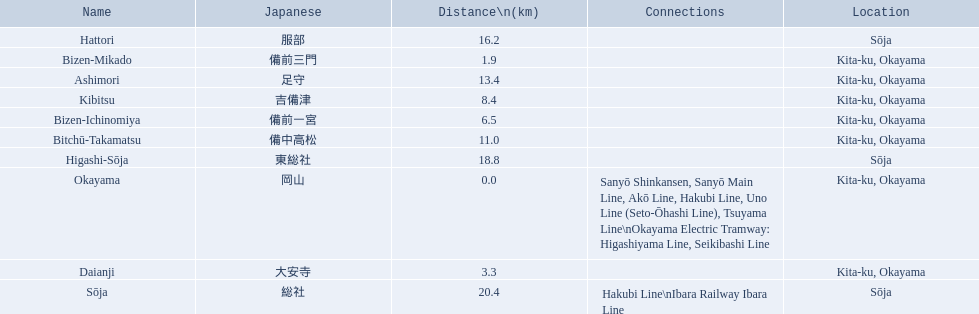What are all of the train names? Okayama, Bizen-Mikado, Daianji, Bizen-Ichinomiya, Kibitsu, Bitchū-Takamatsu, Ashimori, Hattori, Higashi-Sōja, Sōja. What is the distance for each? 0.0, 1.9, 3.3, 6.5, 8.4, 11.0, 13.4, 16.2, 18.8, 20.4. And which train's distance is between 1 and 2 km? Bizen-Mikado. 